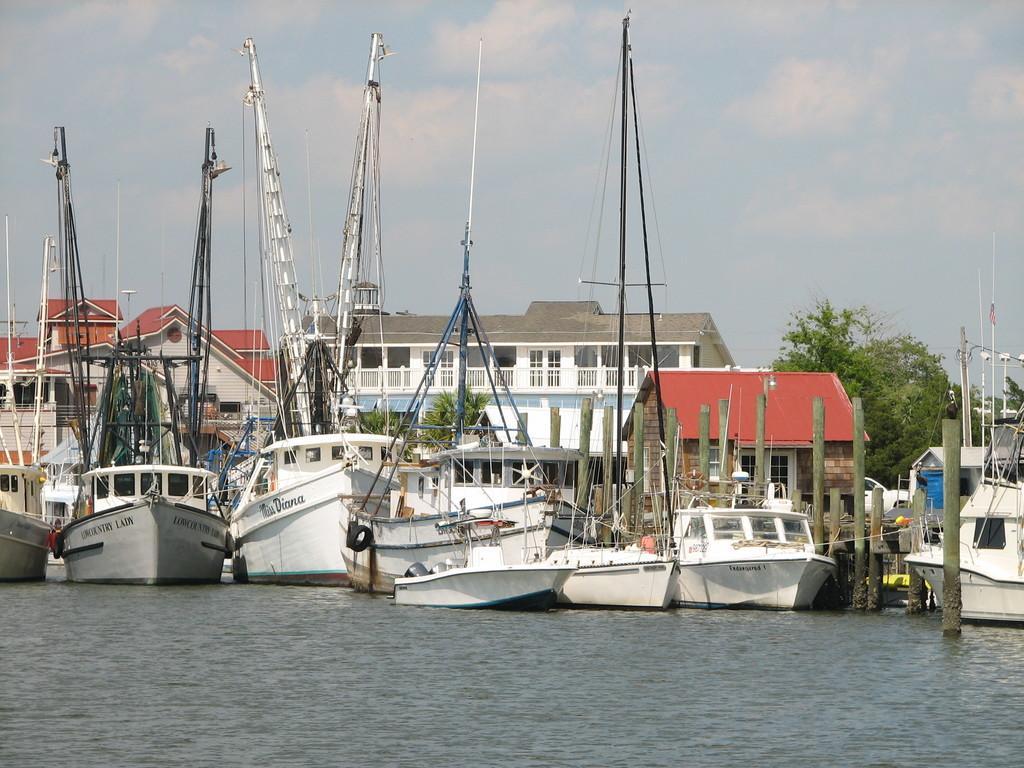How would you summarize this image in a sentence or two? In this image we can see a group of boats with poles and wires in a large water body. We can also see some poles, buildings with windows, trees and the sky which looks cloudy. 